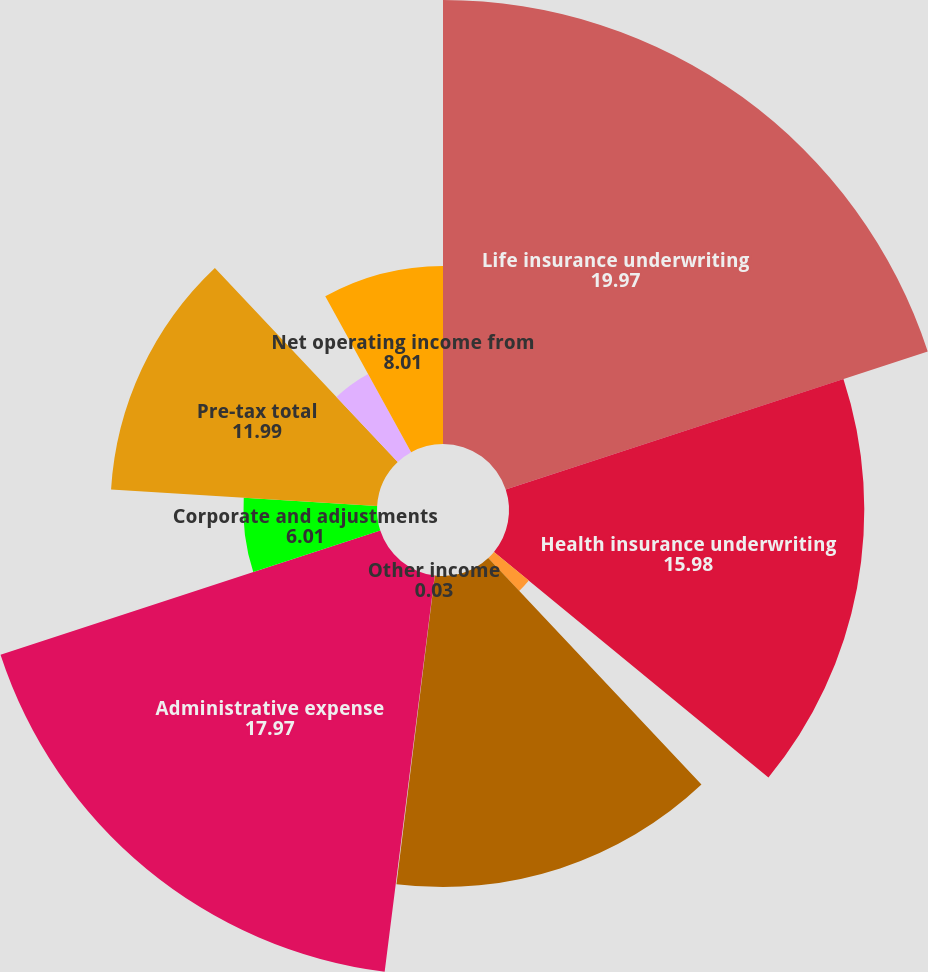<chart> <loc_0><loc_0><loc_500><loc_500><pie_chart><fcel>Life insurance underwriting<fcel>Health insurance underwriting<fcel>Annuity underwriting margin<fcel>Excess investment income<fcel>Other income<fcel>Administrative expense<fcel>Corporate and adjustments<fcel>Pre-tax total<fcel>Applicable taxes (1)<fcel>Net operating income from<nl><fcel>19.97%<fcel>15.98%<fcel>2.03%<fcel>13.99%<fcel>0.03%<fcel>17.97%<fcel>6.01%<fcel>11.99%<fcel>4.02%<fcel>8.01%<nl></chart> 